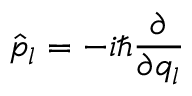<formula> <loc_0><loc_0><loc_500><loc_500>\hat { p } _ { l } = - i \hbar { } \partial } { \partial q _ { l } }</formula> 